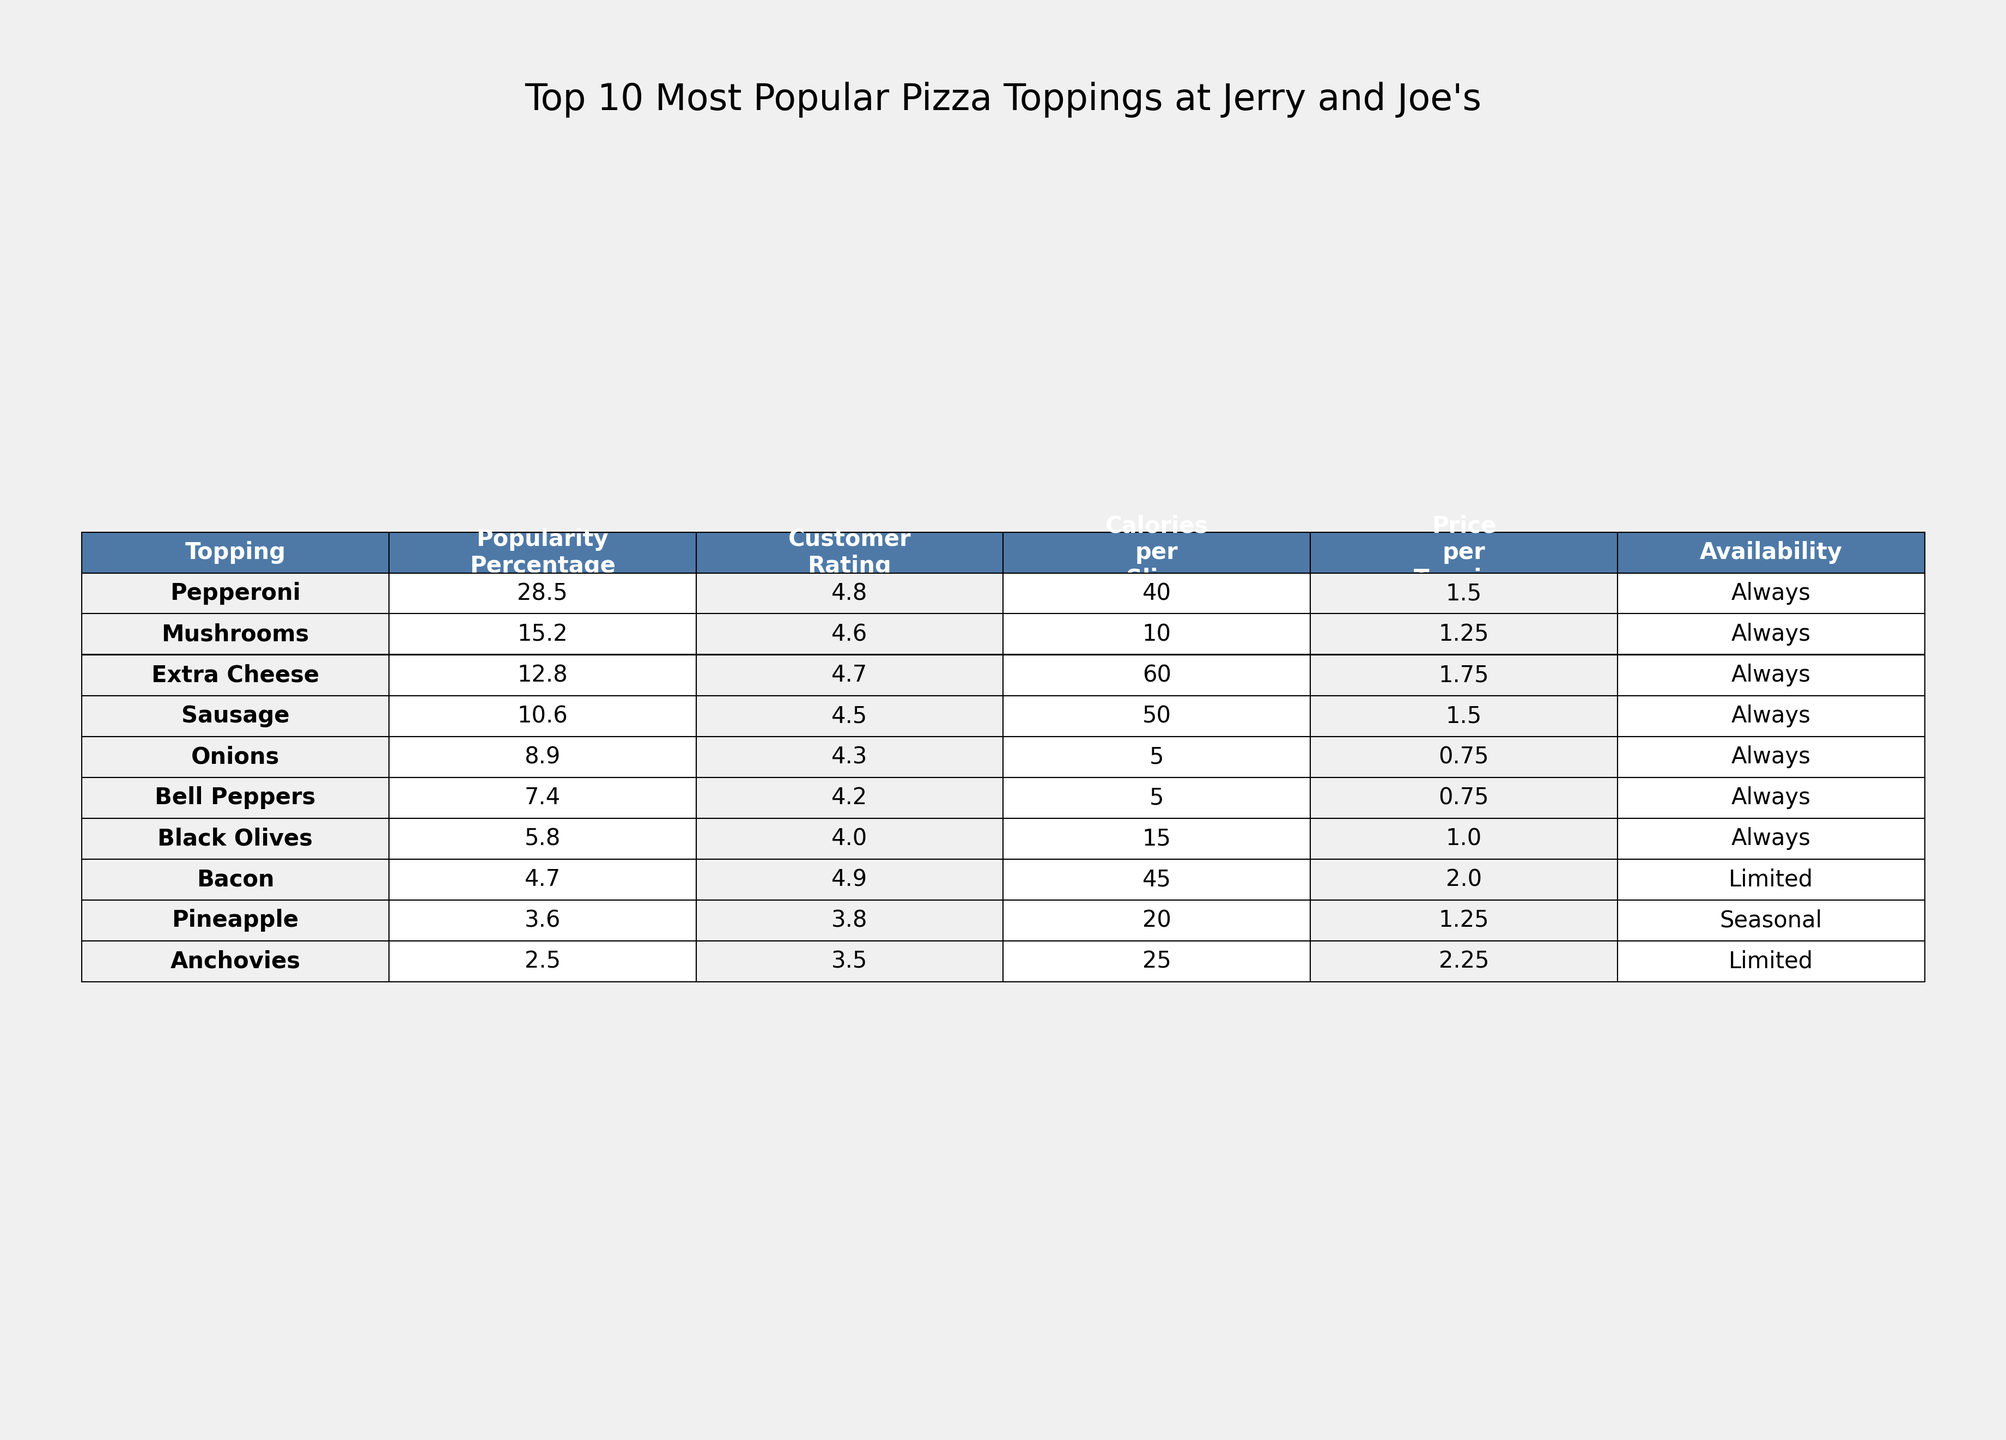What is the most popular topping at Jerry and Joe's Pizza? The most popular topping is the one with the highest popularity percentage, which is Pepperoni at 28.5%.
Answer: Pepperoni What is the customer rating for Mushrooms? The customer rating for Mushrooms is listed in the table, which shows it as 4.6.
Answer: 4.6 How many calories are in a slice of Extra Cheese pizza? The table states that a slice of Extra Cheese pizza contains 60 calories.
Answer: 60 Which topping has the lowest popularity percentage? To find the lowest popularity, I look through the percentage column and see that Anchovies has the lowest at 2.5%.
Answer: Anchovies Is Bacon available all year round? The table indicates that Bacon has a "Limited" availability, meaning it is not available all year round.
Answer: No What is the average customer rating of the top three toppings? The top three toppings are Pepperoni (4.8), Mushrooms (4.6), and Extra Cheese (4.7). The average is (4.8 + 4.6 + 4.7) / 3 = 4.7.
Answer: 4.7 What is the total price for adding all ten toppings? The total price is calculated by summing up all the price values per topping: 1.50 + 1.25 + 1.75 + 1.50 + 0.75 + 0.75 + 1.00 + 2.00 + 1.25 + 2.25 = 13.00.
Answer: 13.00 How many toppings have a customer rating of 4.5 or higher? From the table, I filter toppings with ratings 4.5 and above: Pepperoni, Mushrooms, Extra Cheese, Sausage, Onions, Bacon. That's a total of 6 toppings.
Answer: 6 What percentage of the total popularity do Pineapple and Anchovies together represent? First, I add their popularity percentages: Pineapple (3.6%) + Anchovies (2.5%) = 6.1%.
Answer: 6.1% Which two toppings have the same availability status? Comparing the availability, I see that both Mushrooms and Pepperoni are listed as "Always" available.
Answer: Mushrooms and Pepperoni 